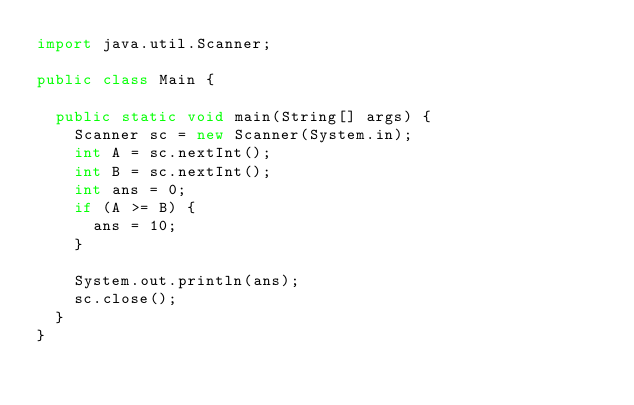Convert code to text. <code><loc_0><loc_0><loc_500><loc_500><_Java_>import java.util.Scanner;

public class Main {

	public static void main(String[] args) {
		Scanner sc = new Scanner(System.in);
		int A = sc.nextInt();
		int B = sc.nextInt();
		int ans = 0;
		if (A >= B) {
			ans = 10;
		}

		System.out.println(ans);
		sc.close();
	}
}
</code> 